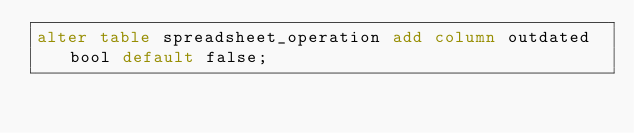Convert code to text. <code><loc_0><loc_0><loc_500><loc_500><_SQL_>alter table spreadsheet_operation add column outdated bool default false;
</code> 